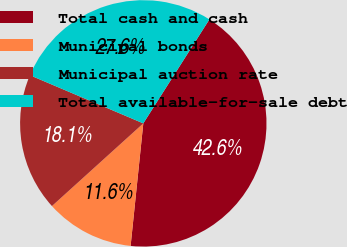Convert chart to OTSL. <chart><loc_0><loc_0><loc_500><loc_500><pie_chart><fcel>Total cash and cash<fcel>Municipal bonds<fcel>Municipal auction rate<fcel>Total available-for-sale debt<nl><fcel>42.63%<fcel>11.65%<fcel>18.1%<fcel>27.62%<nl></chart> 